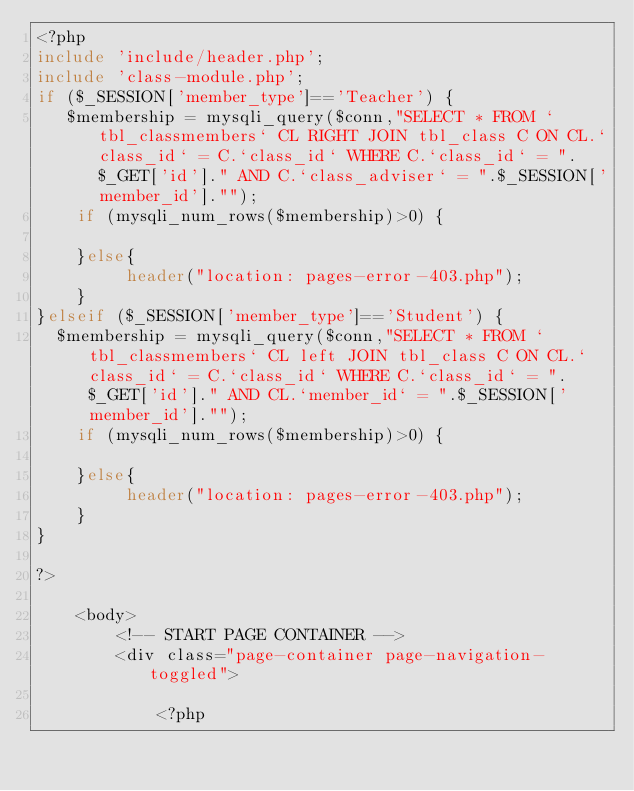Convert code to text. <code><loc_0><loc_0><loc_500><loc_500><_PHP_><?php
include 'include/header.php';
include 'class-module.php';
if ($_SESSION['member_type']=='Teacher') {
   $membership = mysqli_query($conn,"SELECT * FROM `tbl_classmembers` CL RIGHT JOIN tbl_class C ON CL.`class_id` = C.`class_id` WHERE C.`class_id` = ".$_GET['id']." AND C.`class_adviser` = ".$_SESSION['member_id']."");
    if (mysqli_num_rows($membership)>0) {
       
    }else{
         header("location: pages-error-403.php");
    }
}elseif ($_SESSION['member_type']=='Student') {
  $membership = mysqli_query($conn,"SELECT * FROM `tbl_classmembers` CL left JOIN tbl_class C ON CL.`class_id` = C.`class_id` WHERE C.`class_id` = ".$_GET['id']." AND CL.`member_id` = ".$_SESSION['member_id']."");
    if (mysqli_num_rows($membership)>0) {
       
    }else{
         header("location: pages-error-403.php");
    }
}
    
?>

    <body>
        <!-- START PAGE CONTAINER -->
        <div class="page-container page-navigation-toggled">
            
            <?php</code> 